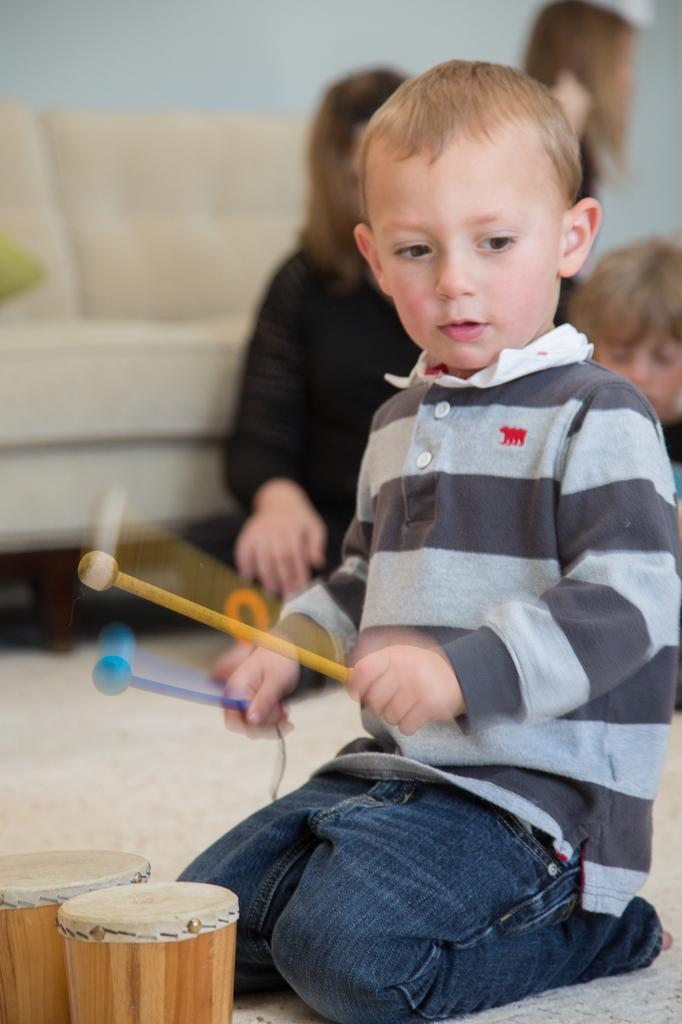What is the boy in the image doing? The boy is playing drums. What is the boy holding in the image? The boy is holding sticks. Can you describe the setting where the boy is playing drums? There are two kids and a woman sitting in the background, and there is a couch in the image. How many icicles can be seen hanging from the ceiling in the image? There are no icicles present in the image. What type of current is powering the drum set in the image? The image does not provide information about the power source for the drum set. 